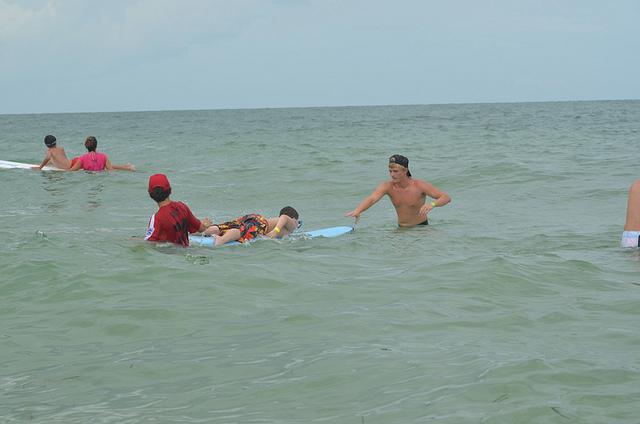How deep is the water on the shirtless man?
Concise answer only. Waist deep. Are the people swimming?
Be succinct. Yes. Is this a life-saving class?
Give a very brief answer. Yes. What are the people sitting in?
Give a very brief answer. Water. What does the man on the left have in this hands?
Keep it brief. Surfboard. Are these swimmers competing?
Quick response, please. No. What are the people riding on?
Be succinct. Surfboard. 